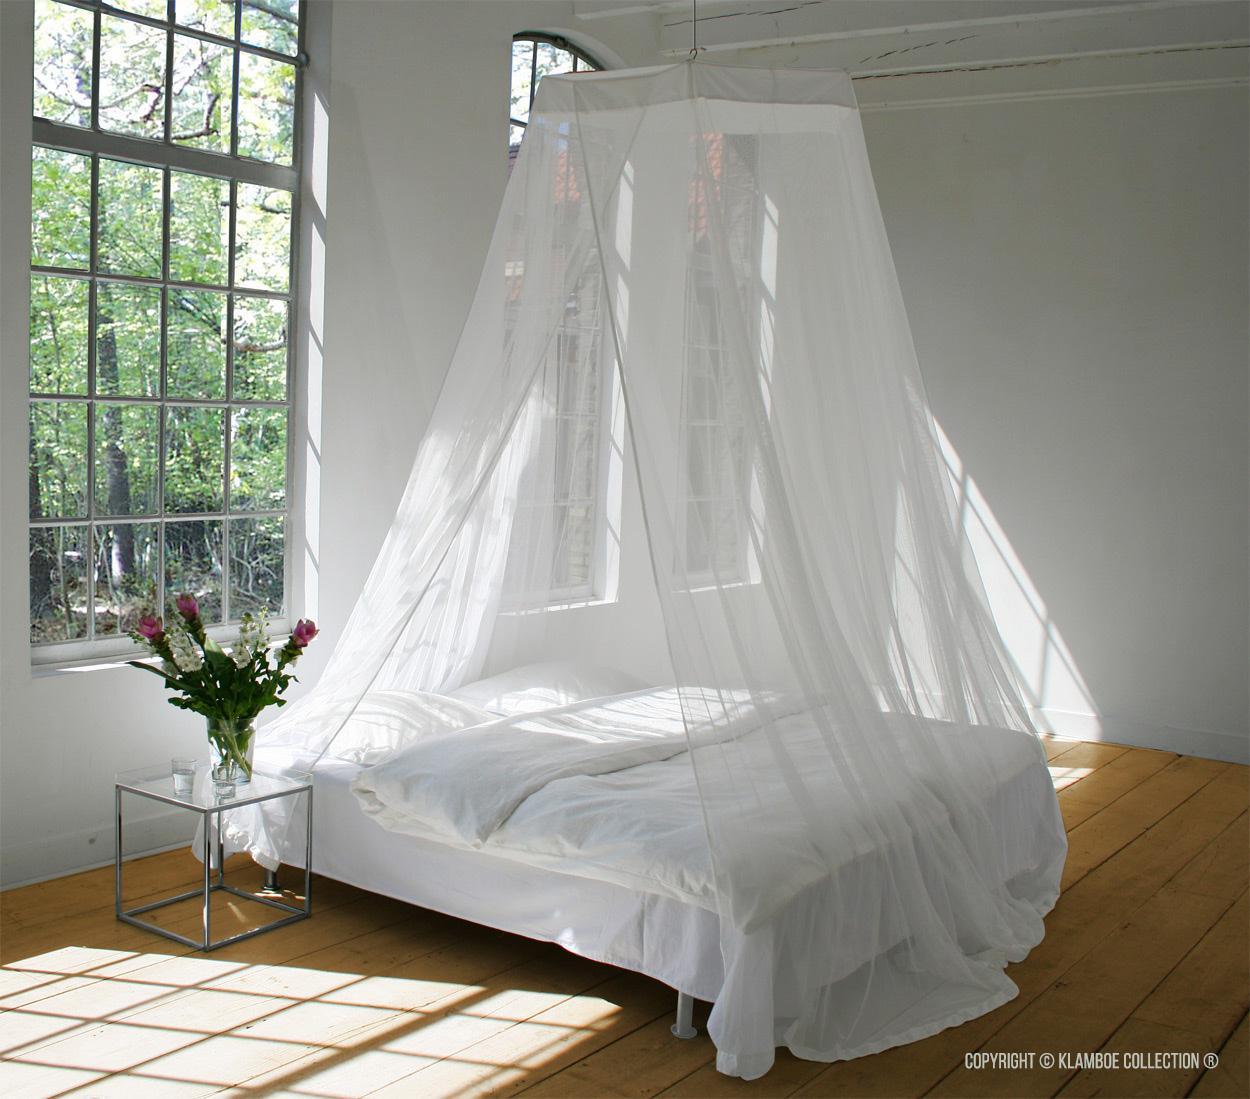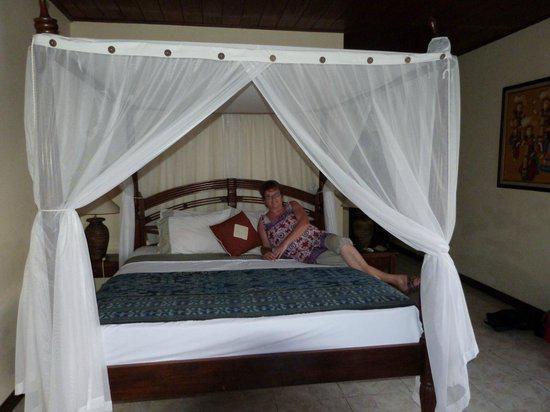The first image is the image on the left, the second image is the image on the right. Considering the images on both sides, is "The bed canopy in the right image is purple." valid? Answer yes or no. No. The first image is the image on the left, the second image is the image on the right. Analyze the images presented: Is the assertion "Each bed is covered by a white canape." valid? Answer yes or no. Yes. 